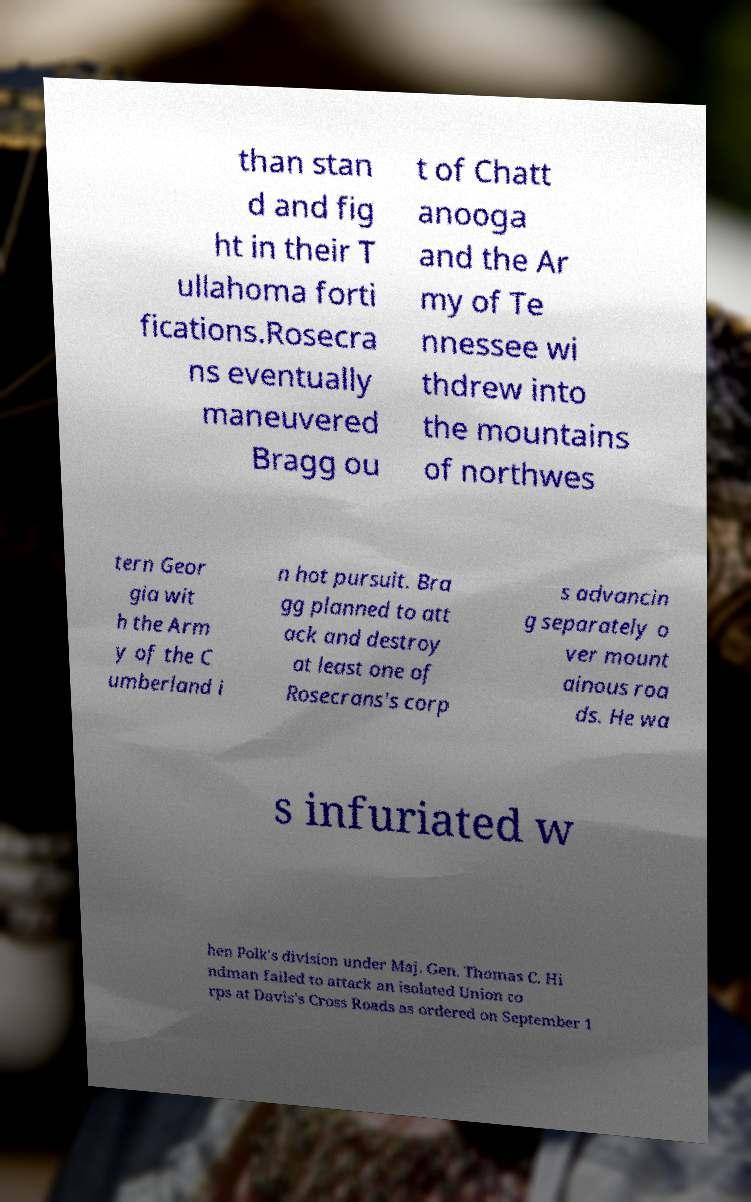What messages or text are displayed in this image? I need them in a readable, typed format. than stan d and fig ht in their T ullahoma forti fications.Rosecra ns eventually maneuvered Bragg ou t of Chatt anooga and the Ar my of Te nnessee wi thdrew into the mountains of northwes tern Geor gia wit h the Arm y of the C umberland i n hot pursuit. Bra gg planned to att ack and destroy at least one of Rosecrans's corp s advancin g separately o ver mount ainous roa ds. He wa s infuriated w hen Polk's division under Maj. Gen. Thomas C. Hi ndman failed to attack an isolated Union co rps at Davis's Cross Roads as ordered on September 1 